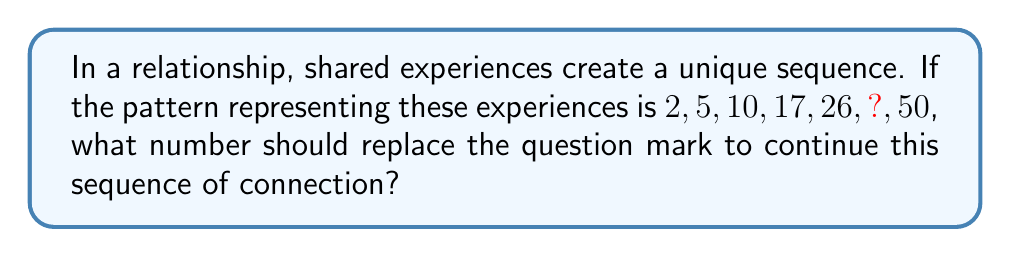Could you help me with this problem? To solve this problem, let's analyze the pattern:

1) First, calculate the differences between consecutive terms:
   $5 - 2 = 3$
   $10 - 5 = 5$
   $17 - 10 = 7$
   $26 - 17 = 9$
   $50 - ? = ?$

2) We can see that the differences form a sequence: 3, 5, 7, 9, ...
   This is an arithmetic sequence with a common difference of 2.

3) The next difference in this sequence would be 11.

4) Now, we can find the missing term by adding this difference to the previous term:
   $26 + 11 = 37$

5) Let's verify:
   $37 - 26 = 11$
   $50 - 37 = 13$

   This fits the pattern of increasing differences.

Therefore, the number that should replace the question mark is 37, symbolizing the continued growth and deepening of shared experiences in the relationship.
Answer: 37 